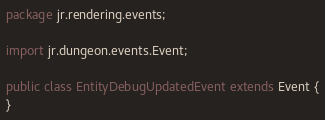<code> <loc_0><loc_0><loc_500><loc_500><_Java_>package jr.rendering.events;

import jr.dungeon.events.Event;

public class EntityDebugUpdatedEvent extends Event {
}
</code> 